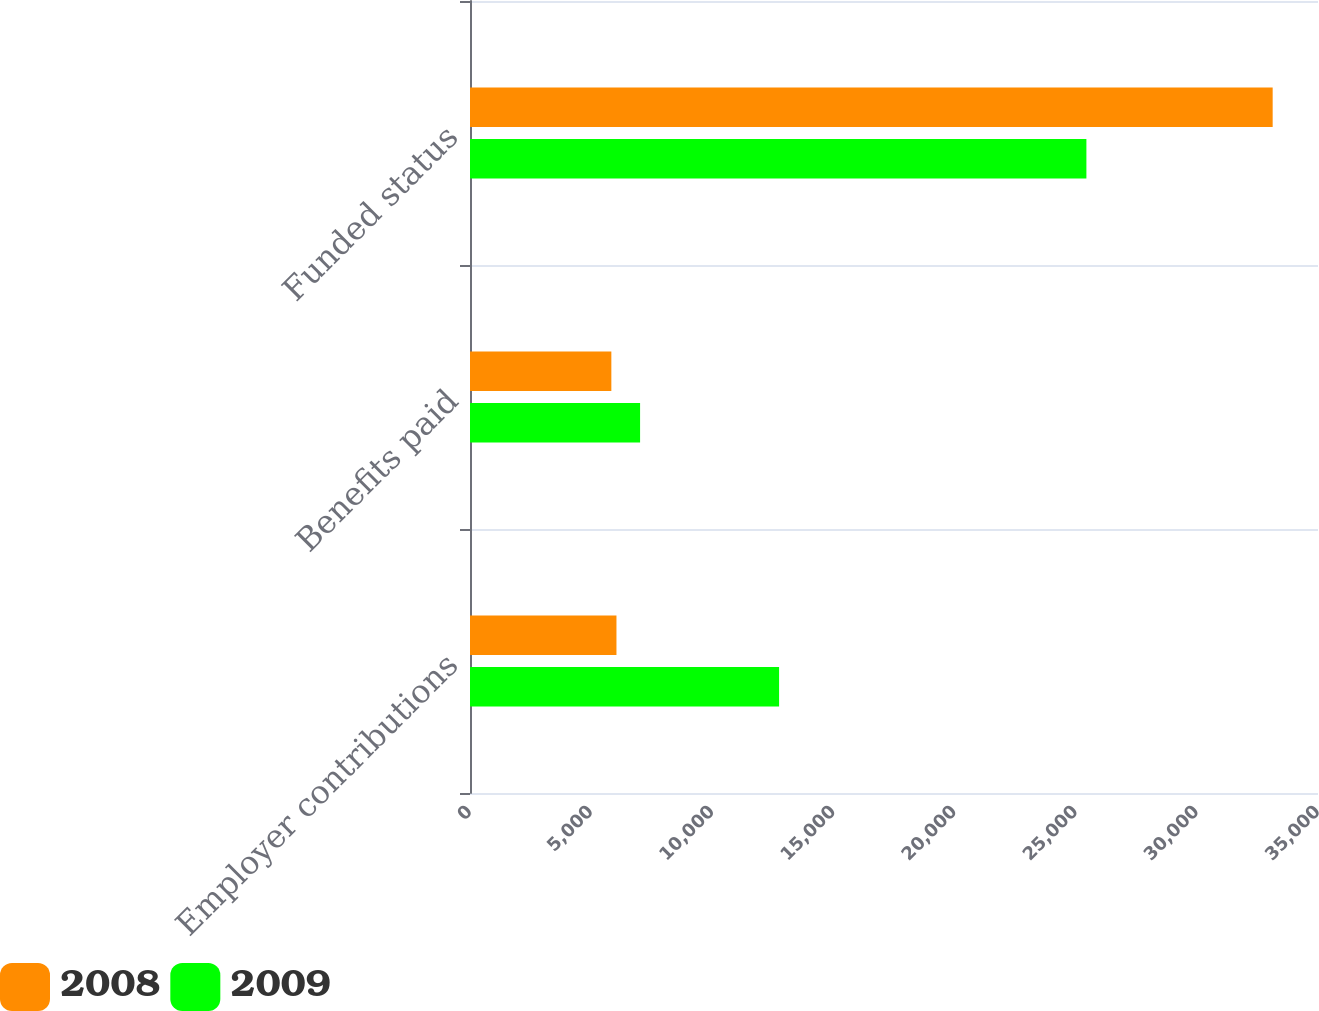Convert chart to OTSL. <chart><loc_0><loc_0><loc_500><loc_500><stacked_bar_chart><ecel><fcel>Employer contributions<fcel>Benefits paid<fcel>Funded status<nl><fcel>2008<fcel>6045<fcel>5834<fcel>33129<nl><fcel>2009<fcel>12757<fcel>7020<fcel>25441<nl></chart> 